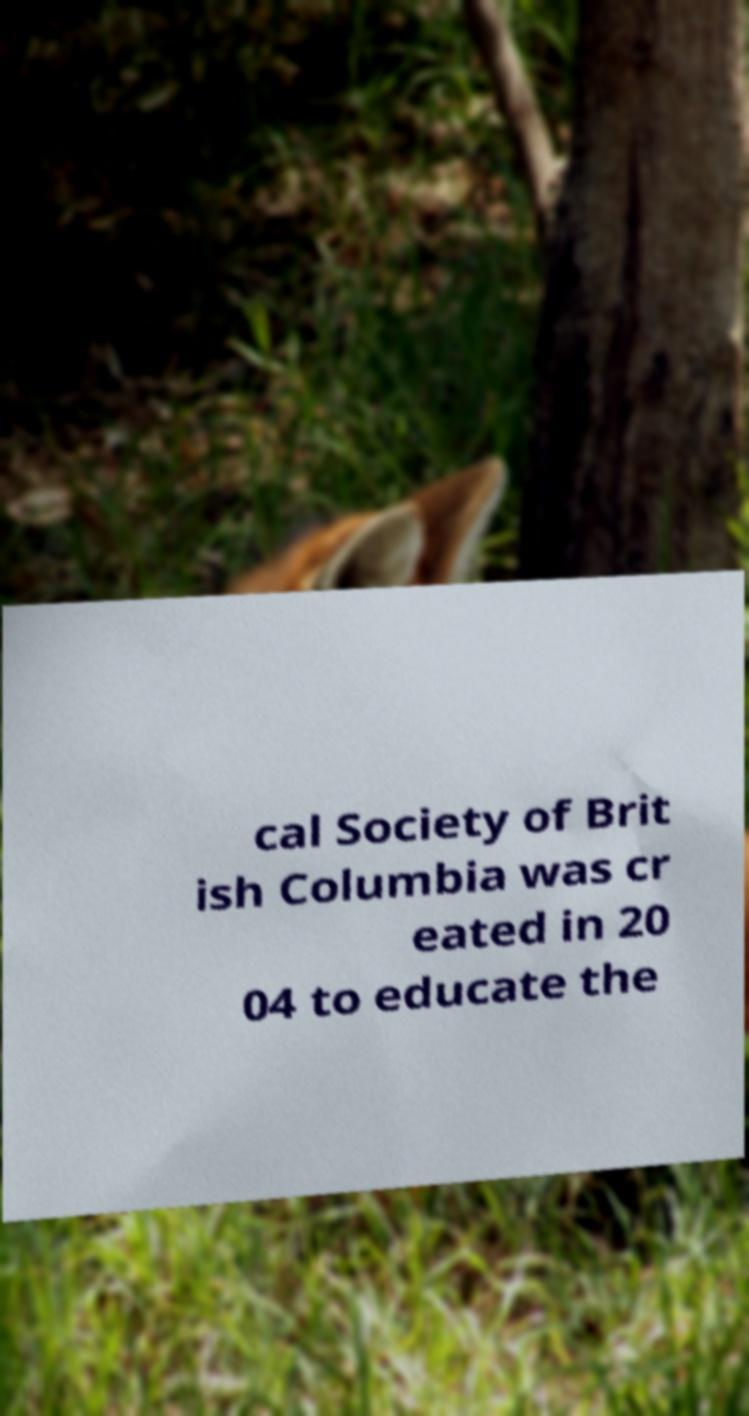For documentation purposes, I need the text within this image transcribed. Could you provide that? cal Society of Brit ish Columbia was cr eated in 20 04 to educate the 